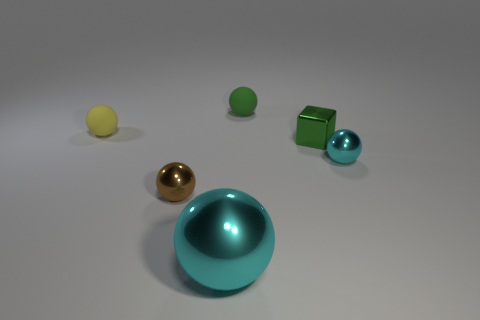What number of other large cyan shiny objects are the same shape as the big cyan thing?
Your answer should be compact. 0. What is the material of the green thing that is in front of the object that is left of the tiny brown sphere?
Your answer should be very brief. Metal. What is the shape of the thing that is the same color as the large metallic sphere?
Provide a succinct answer. Sphere. Is there a large thing that has the same material as the small brown sphere?
Your response must be concise. Yes. The small brown object is what shape?
Your response must be concise. Sphere. What number of metallic cylinders are there?
Offer a terse response. 0. The small metal ball that is to the left of the green metallic thing on the right side of the tiny brown thing is what color?
Ensure brevity in your answer.  Brown. The cube that is the same size as the green ball is what color?
Give a very brief answer. Green. Are there any tiny rubber things that have the same color as the big thing?
Your response must be concise. No. Are any gray rubber objects visible?
Provide a succinct answer. No. 